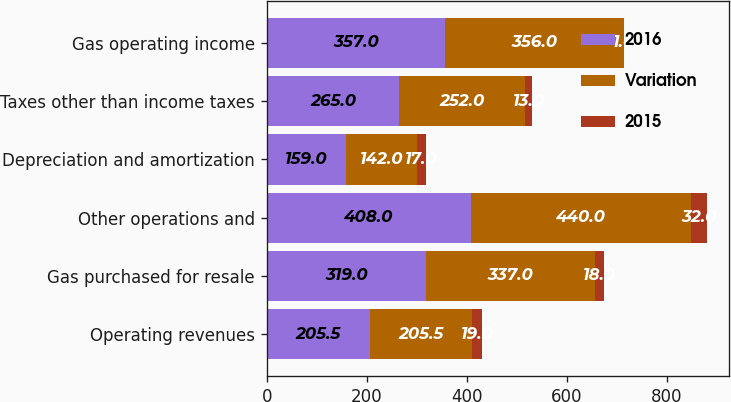Convert chart to OTSL. <chart><loc_0><loc_0><loc_500><loc_500><stacked_bar_chart><ecel><fcel>Operating revenues<fcel>Gas purchased for resale<fcel>Other operations and<fcel>Depreciation and amortization<fcel>Taxes other than income taxes<fcel>Gas operating income<nl><fcel>2016<fcel>205.5<fcel>319<fcel>408<fcel>159<fcel>265<fcel>357<nl><fcel>Variation<fcel>205.5<fcel>337<fcel>440<fcel>142<fcel>252<fcel>356<nl><fcel>2015<fcel>19<fcel>18<fcel>32<fcel>17<fcel>13<fcel>1<nl></chart> 